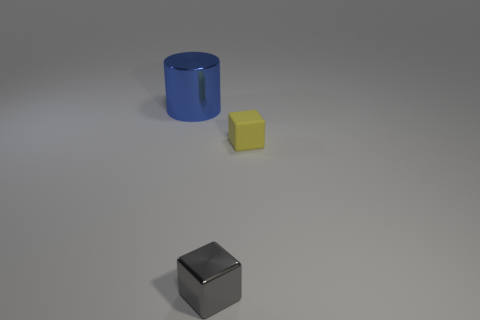Add 3 small yellow matte objects. How many objects exist? 6 Subtract all cyan blocks. Subtract all brown spheres. How many blocks are left? 2 Subtract all cylinders. How many objects are left? 2 Add 2 yellow rubber cubes. How many yellow rubber cubes exist? 3 Subtract 0 green blocks. How many objects are left? 3 Subtract all tiny green rubber cylinders. Subtract all big metallic things. How many objects are left? 2 Add 3 small yellow matte objects. How many small yellow matte objects are left? 4 